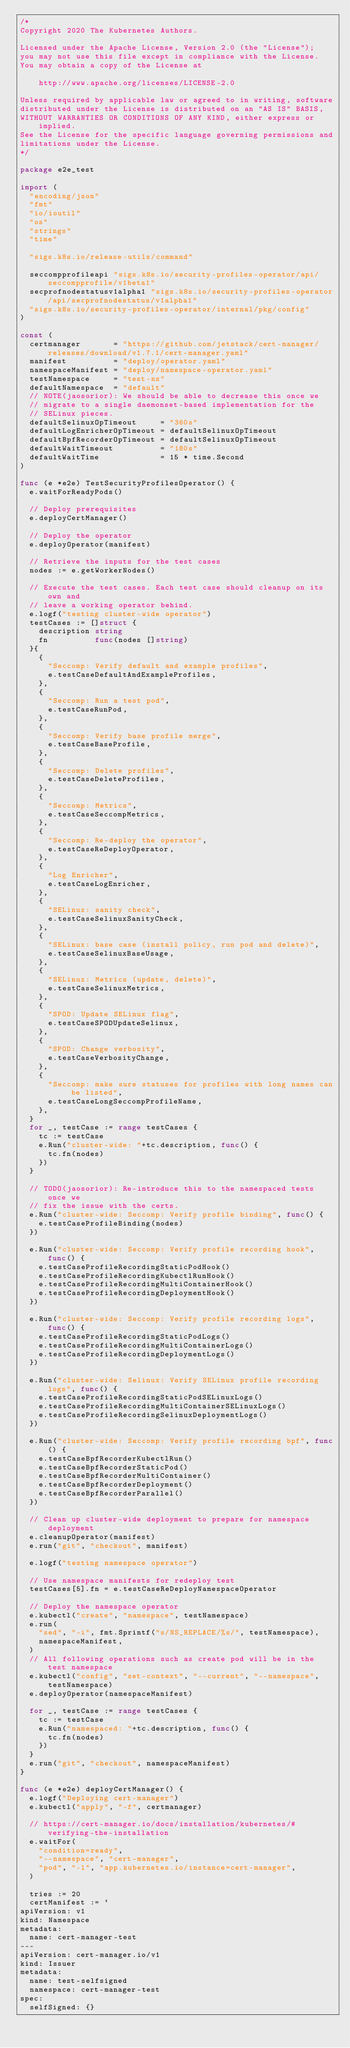Convert code to text. <code><loc_0><loc_0><loc_500><loc_500><_Go_>/*
Copyright 2020 The Kubernetes Authors.

Licensed under the Apache License, Version 2.0 (the "License");
you may not use this file except in compliance with the License.
You may obtain a copy of the License at

    http://www.apache.org/licenses/LICENSE-2.0

Unless required by applicable law or agreed to in writing, software
distributed under the License is distributed on an "AS IS" BASIS,
WITHOUT WARRANTIES OR CONDITIONS OF ANY KIND, either express or implied.
See the License for the specific language governing permissions and
limitations under the License.
*/

package e2e_test

import (
	"encoding/json"
	"fmt"
	"io/ioutil"
	"os"
	"strings"
	"time"

	"sigs.k8s.io/release-utils/command"

	seccompprofileapi "sigs.k8s.io/security-profiles-operator/api/seccompprofile/v1beta1"
	secprofnodestatusv1alpha1 "sigs.k8s.io/security-profiles-operator/api/secprofnodestatus/v1alpha1"
	"sigs.k8s.io/security-profiles-operator/internal/pkg/config"
)

const (
	certmanager       = "https://github.com/jetstack/cert-manager/releases/download/v1.7.1/cert-manager.yaml"
	manifest          = "deploy/operator.yaml"
	namespaceManifest = "deploy/namespace-operator.yaml"
	testNamespace     = "test-ns"
	defaultNamespace  = "default"
	// NOTE(jaosorior): We should be able to decrease this once we
	// migrate to a single daemonset-based implementation for the
	// SELinux pieces.
	defaultSelinuxOpTimeout     = "360s"
	defaultLogEnricherOpTimeout = defaultSelinuxOpTimeout
	defaultBpfRecorderOpTimeout = defaultSelinuxOpTimeout
	defaultWaitTimeout          = "180s"
	defaultWaitTime             = 15 * time.Second
)

func (e *e2e) TestSecurityProfilesOperator() {
	e.waitForReadyPods()

	// Deploy prerequisites
	e.deployCertManager()

	// Deploy the operator
	e.deployOperator(manifest)

	// Retrieve the inputs for the test cases
	nodes := e.getWorkerNodes()

	// Execute the test cases. Each test case should cleanup on its own and
	// leave a working operator behind.
	e.logf("testing cluster-wide operator")
	testCases := []struct {
		description string
		fn          func(nodes []string)
	}{
		{
			"Seccomp: Verify default and example profiles",
			e.testCaseDefaultAndExampleProfiles,
		},
		{
			"Seccomp: Run a test pod",
			e.testCaseRunPod,
		},
		{
			"Seccomp: Verify base profile merge",
			e.testCaseBaseProfile,
		},
		{
			"Seccomp: Delete profiles",
			e.testCaseDeleteProfiles,
		},
		{
			"Seccomp: Metrics",
			e.testCaseSeccompMetrics,
		},
		{
			"Seccomp: Re-deploy the operator",
			e.testCaseReDeployOperator,
		},
		{
			"Log Enricher",
			e.testCaseLogEnricher,
		},
		{
			"SELinux: sanity check",
			e.testCaseSelinuxSanityCheck,
		},
		{
			"SELinux: base case (install policy, run pod and delete)",
			e.testCaseSelinuxBaseUsage,
		},
		{
			"SELinux: Metrics (update, delete)",
			e.testCaseSelinuxMetrics,
		},
		{
			"SPOD: Update SELinux flag",
			e.testCaseSPODUpdateSelinux,
		},
		{
			"SPOD: Change verbosity",
			e.testCaseVerbosityChange,
		},
		{
			"Seccomp: make sure statuses for profiles with long names can be listed",
			e.testCaseLongSeccompProfileName,
		},
	}
	for _, testCase := range testCases {
		tc := testCase
		e.Run("cluster-wide: "+tc.description, func() {
			tc.fn(nodes)
		})
	}

	// TODO(jaosorior): Re-introduce this to the namespaced tests once we
	// fix the issue with the certs.
	e.Run("cluster-wide: Seccomp: Verify profile binding", func() {
		e.testCaseProfileBinding(nodes)
	})

	e.Run("cluster-wide: Seccomp: Verify profile recording hook", func() {
		e.testCaseProfileRecordingStaticPodHook()
		e.testCaseProfileRecordingKubectlRunHook()
		e.testCaseProfileRecordingMultiContainerHook()
		e.testCaseProfileRecordingDeploymentHook()
	})

	e.Run("cluster-wide: Seccomp: Verify profile recording logs", func() {
		e.testCaseProfileRecordingStaticPodLogs()
		e.testCaseProfileRecordingMultiContainerLogs()
		e.testCaseProfileRecordingDeploymentLogs()
	})

	e.Run("cluster-wide: Selinux: Verify SELinux profile recording logs", func() {
		e.testCaseProfileRecordingStaticPodSELinuxLogs()
		e.testCaseProfileRecordingMultiContainerSELinuxLogs()
		e.testCaseProfileRecordingSelinuxDeploymentLogs()
	})

	e.Run("cluster-wide: Seccomp: Verify profile recording bpf", func() {
		e.testCaseBpfRecorderKubectlRun()
		e.testCaseBpfRecorderStaticPod()
		e.testCaseBpfRecorderMultiContainer()
		e.testCaseBpfRecorderDeployment()
		e.testCaseBpfRecorderParallel()
	})

	// Clean up cluster-wide deployment to prepare for namespace deployment
	e.cleanupOperator(manifest)
	e.run("git", "checkout", manifest)

	e.logf("testing namespace operator")

	// Use namespace manifests for redeploy test
	testCases[5].fn = e.testCaseReDeployNamespaceOperator

	// Deploy the namespace operator
	e.kubectl("create", "namespace", testNamespace)
	e.run(
		"sed", "-i", fmt.Sprintf("s/NS_REPLACE/%s/", testNamespace),
		namespaceManifest,
	)
	// All following operations such as create pod will be in the test namespace
	e.kubectl("config", "set-context", "--current", "--namespace", testNamespace)
	e.deployOperator(namespaceManifest)

	for _, testCase := range testCases {
		tc := testCase
		e.Run("namespaced: "+tc.description, func() {
			tc.fn(nodes)
		})
	}
	e.run("git", "checkout", namespaceManifest)
}

func (e *e2e) deployCertManager() {
	e.logf("Deploying cert-manager")
	e.kubectl("apply", "-f", certmanager)

	// https://cert-manager.io/docs/installation/kubernetes/#verifying-the-installation
	e.waitFor(
		"condition=ready",
		"--namespace", "cert-manager",
		"pod", "-l", "app.kubernetes.io/instance=cert-manager",
	)

	tries := 20
	certManifest := `
apiVersion: v1
kind: Namespace
metadata:
  name: cert-manager-test
---
apiVersion: cert-manager.io/v1
kind: Issuer
metadata:
  name: test-selfsigned
  namespace: cert-manager-test
spec:
  selfSigned: {}</code> 